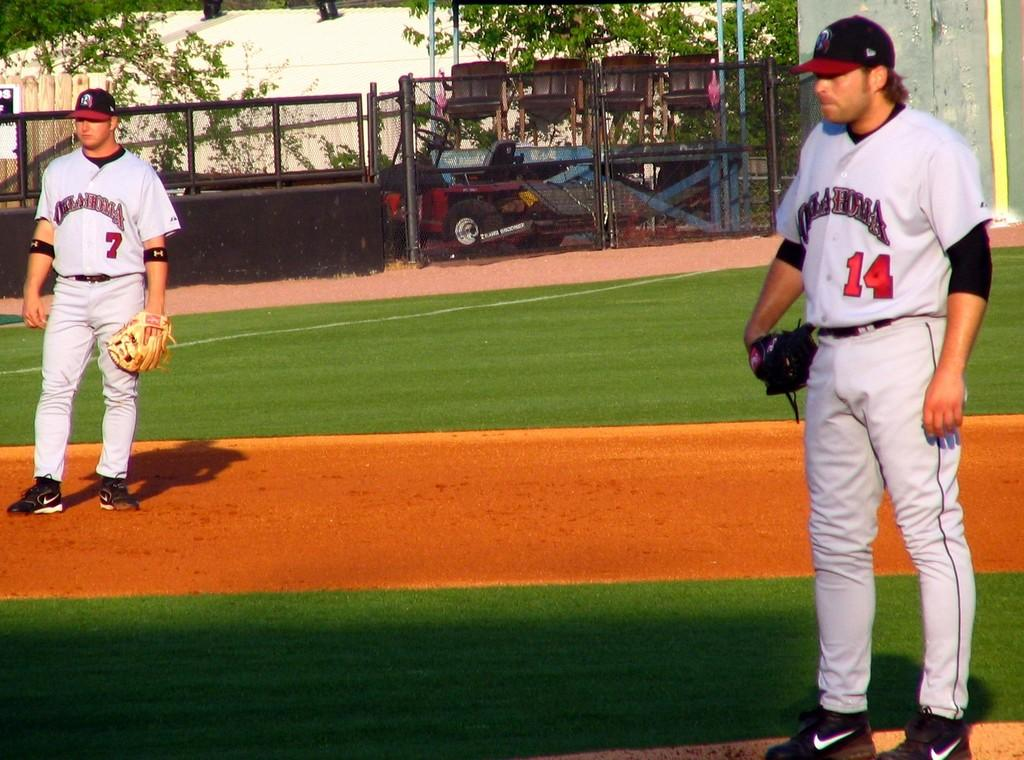<image>
Present a compact description of the photo's key features. Two baseball players on the Oklahoma team stand on the field. 